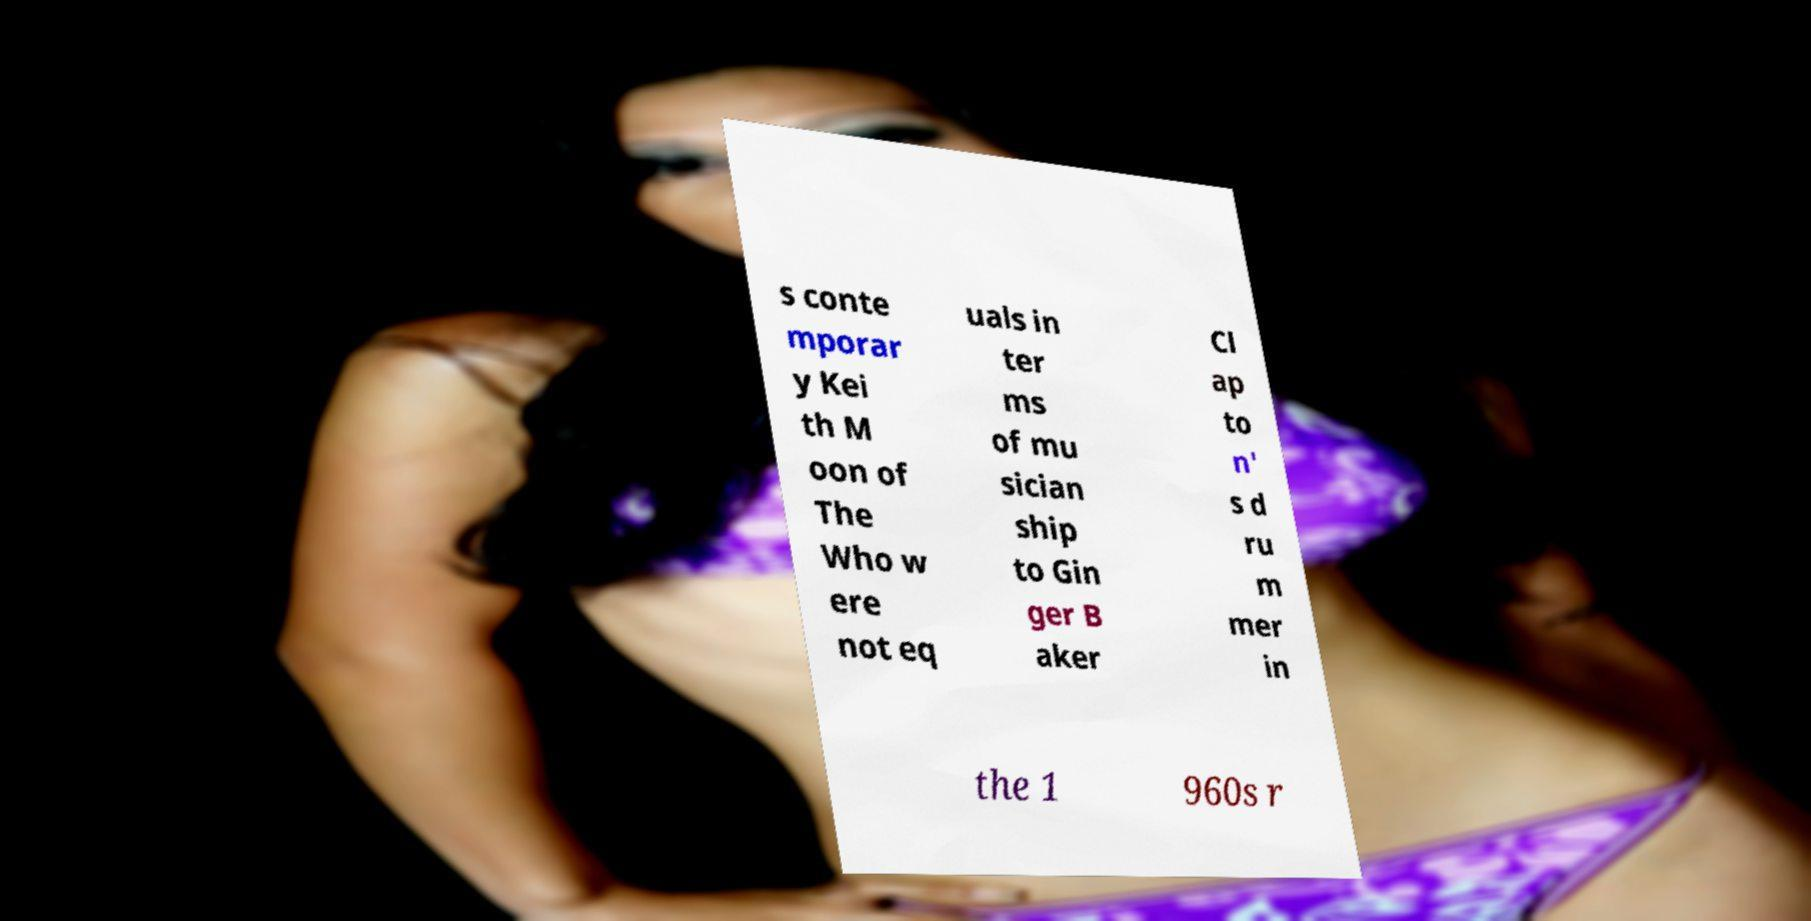Please identify and transcribe the text found in this image. s conte mporar y Kei th M oon of The Who w ere not eq uals in ter ms of mu sician ship to Gin ger B aker Cl ap to n' s d ru m mer in the 1 960s r 